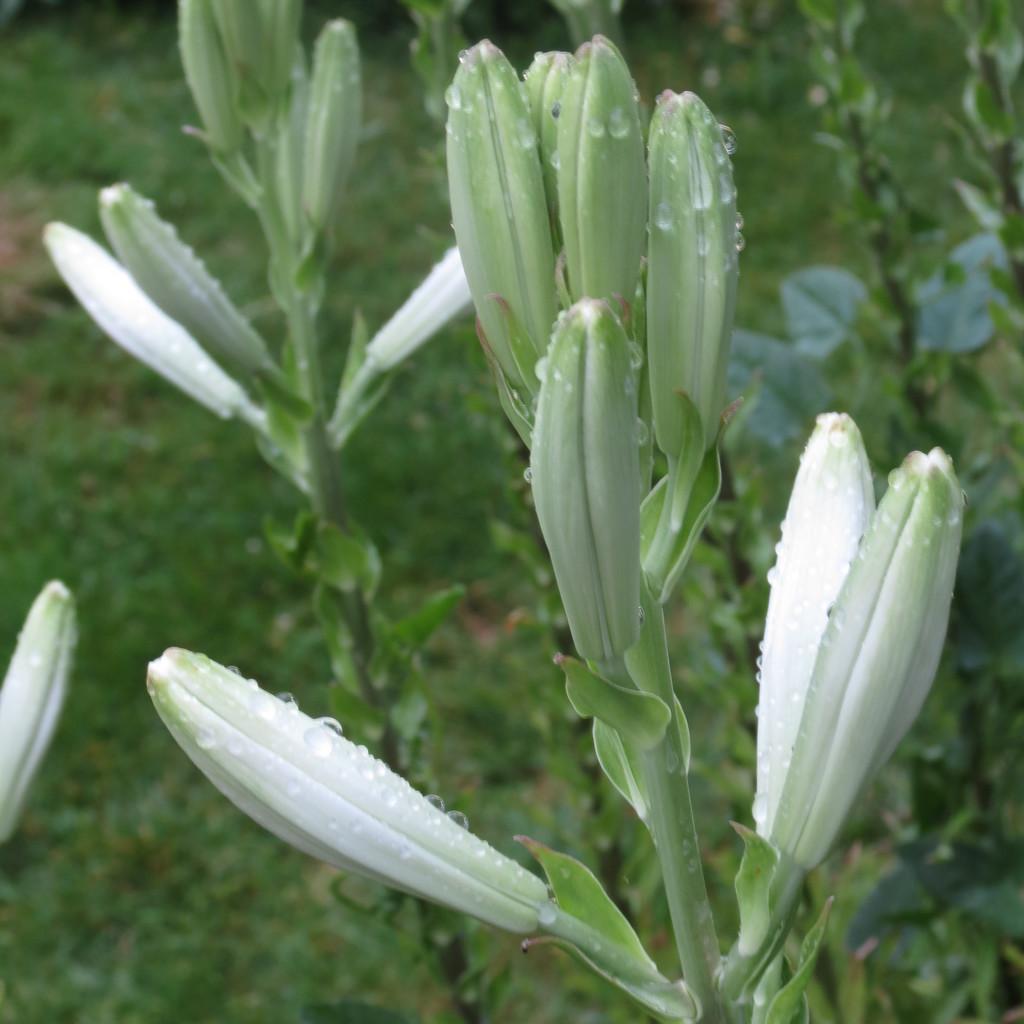In one or two sentences, can you explain what this image depicts? In a given image I can see a plants. 